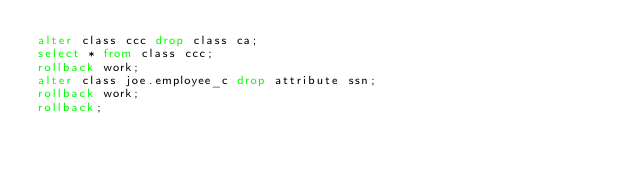Convert code to text. <code><loc_0><loc_0><loc_500><loc_500><_SQL_>alter class ccc drop class ca;
select * from class ccc;
rollback work;
alter class joe.employee_c drop attribute ssn;
rollback work;
rollback;
</code> 